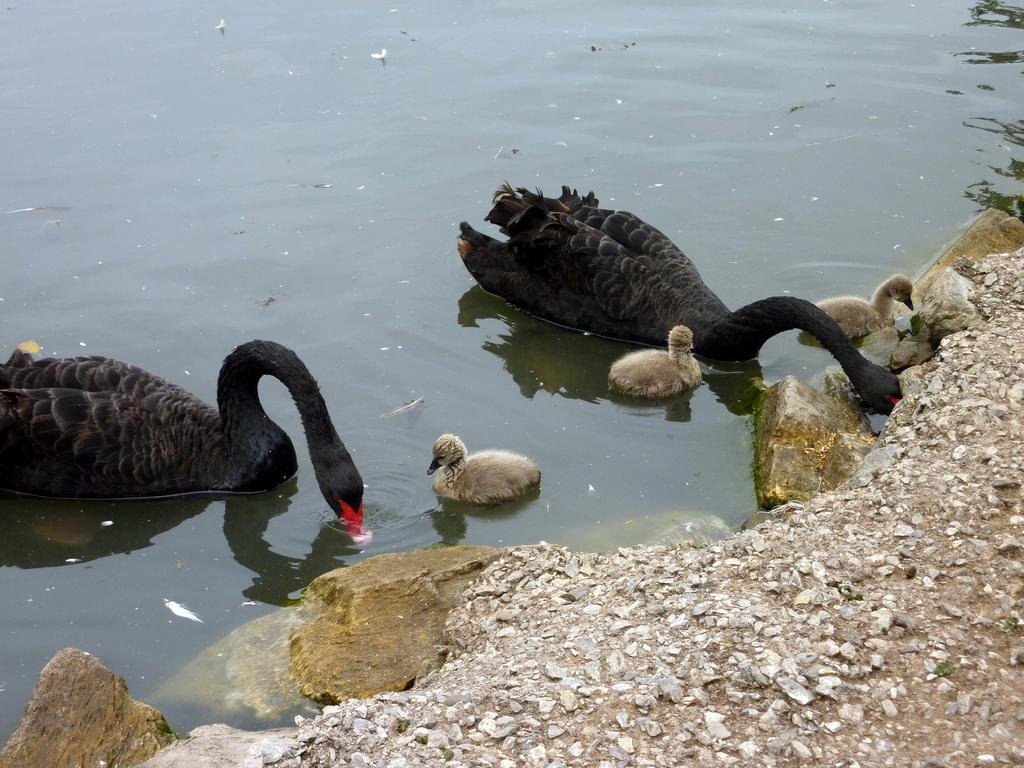What type of animals can be seen in the image? There are birds in the image. What are the birds doing in the image? The birds are swimming in the water. What can be seen on the right side of the image? There is a land surface visible on the right side of the image. What is the current theory about the condition of the ants in the image? There are no ants present in the image, so it is not possible to discuss their condition or any related theories. 